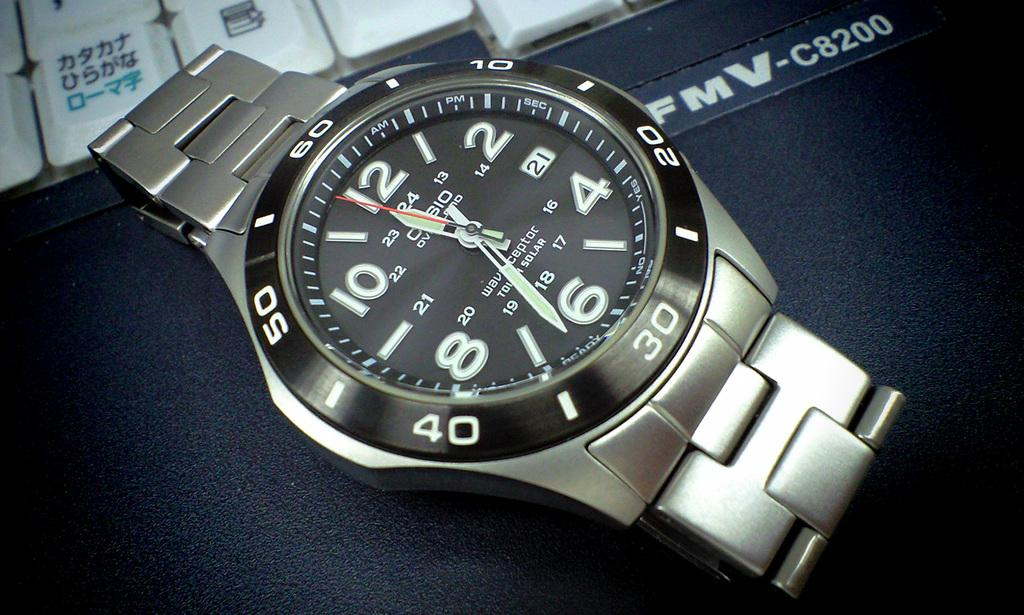<image>
Create a compact narrative representing the image presented. FMV-c8200 watch on  display on a blue counter. 